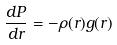Convert formula to latex. <formula><loc_0><loc_0><loc_500><loc_500>\frac { d P } { d r } = - \rho ( r ) g ( r )</formula> 